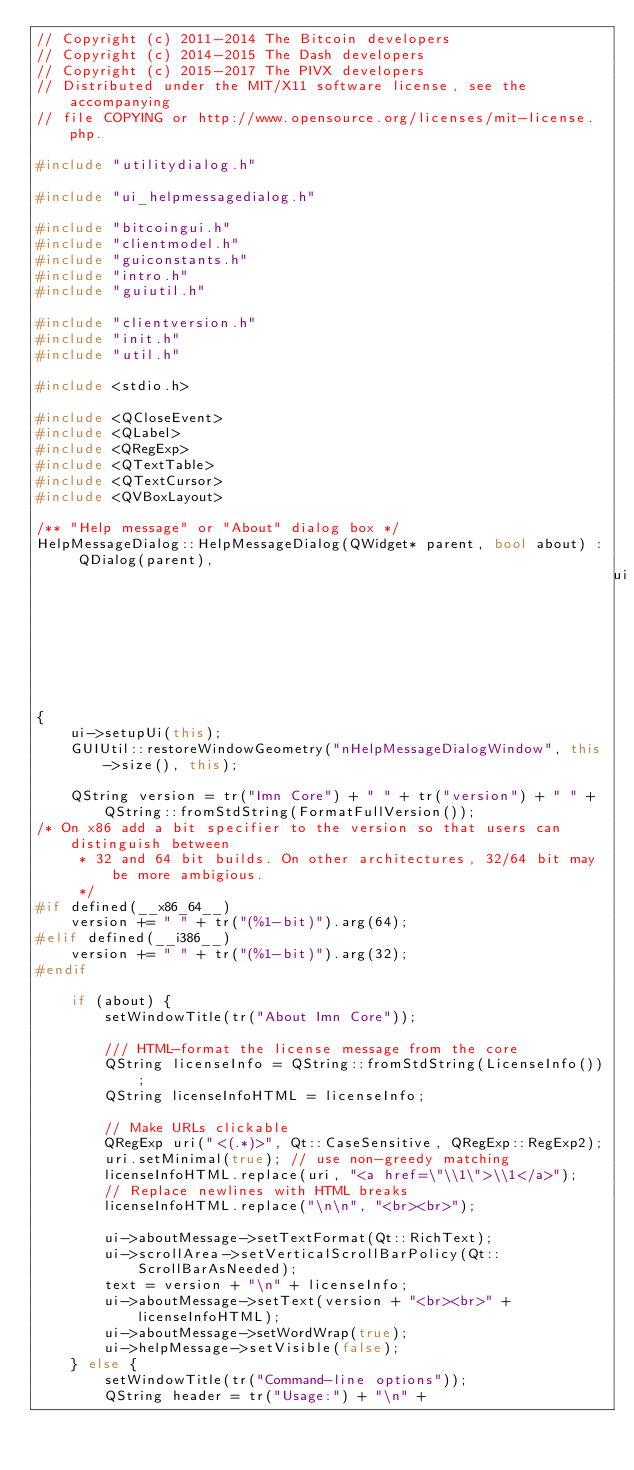Convert code to text. <code><loc_0><loc_0><loc_500><loc_500><_C++_>// Copyright (c) 2011-2014 The Bitcoin developers
// Copyright (c) 2014-2015 The Dash developers
// Copyright (c) 2015-2017 The PIVX developers
// Distributed under the MIT/X11 software license, see the accompanying
// file COPYING or http://www.opensource.org/licenses/mit-license.php.

#include "utilitydialog.h"

#include "ui_helpmessagedialog.h"

#include "bitcoingui.h"
#include "clientmodel.h"
#include "guiconstants.h"
#include "intro.h"
#include "guiutil.h"

#include "clientversion.h"
#include "init.h"
#include "util.h"

#include <stdio.h>

#include <QCloseEvent>
#include <QLabel>
#include <QRegExp>
#include <QTextTable>
#include <QTextCursor>
#include <QVBoxLayout>

/** "Help message" or "About" dialog box */
HelpMessageDialog::HelpMessageDialog(QWidget* parent, bool about) : QDialog(parent),
                                                                    ui(new Ui::HelpMessageDialog)
{
    ui->setupUi(this);
    GUIUtil::restoreWindowGeometry("nHelpMessageDialogWindow", this->size(), this);

    QString version = tr("Imn Core") + " " + tr("version") + " " + QString::fromStdString(FormatFullVersion());
/* On x86 add a bit specifier to the version so that users can distinguish between
     * 32 and 64 bit builds. On other architectures, 32/64 bit may be more ambigious.
     */
#if defined(__x86_64__)
    version += " " + tr("(%1-bit)").arg(64);
#elif defined(__i386__)
    version += " " + tr("(%1-bit)").arg(32);
#endif

    if (about) {
        setWindowTitle(tr("About Imn Core"));

        /// HTML-format the license message from the core
        QString licenseInfo = QString::fromStdString(LicenseInfo());
        QString licenseInfoHTML = licenseInfo;

        // Make URLs clickable
        QRegExp uri("<(.*)>", Qt::CaseSensitive, QRegExp::RegExp2);
        uri.setMinimal(true); // use non-greedy matching
        licenseInfoHTML.replace(uri, "<a href=\"\\1\">\\1</a>");
        // Replace newlines with HTML breaks
        licenseInfoHTML.replace("\n\n", "<br><br>");

        ui->aboutMessage->setTextFormat(Qt::RichText);
        ui->scrollArea->setVerticalScrollBarPolicy(Qt::ScrollBarAsNeeded);
        text = version + "\n" + licenseInfo;
        ui->aboutMessage->setText(version + "<br><br>" + licenseInfoHTML);
        ui->aboutMessage->setWordWrap(true);
        ui->helpMessage->setVisible(false);
    } else {
        setWindowTitle(tr("Command-line options"));
        QString header = tr("Usage:") + "\n" +</code> 